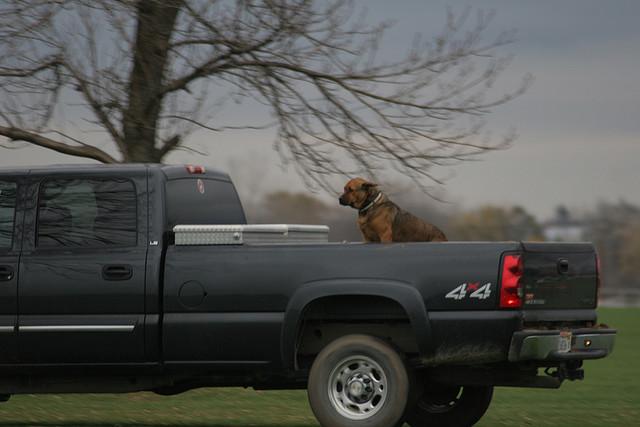What is the truck transporting?
Give a very brief answer. Dog. What color is the truck?
Write a very short answer. Black. What are there names?
Short answer required. Dog. Is this safe for the dog?
Quick response, please. No. What is in the bed of the truck?
Be succinct. Dog. Is the dog on a 4 wheeler?
Quick response, please. No. Is it sunny?
Keep it brief. No. Is the dog in the truck?
Answer briefly. Yes. Is the truck driving?
Keep it brief. Yes. Is it raining out?
Concise answer only. No. Does the tree have leaves?
Give a very brief answer. No. Is there anyone inside the truck?
Short answer required. Yes. Are there stickers on the rear window?
Concise answer only. Yes. What type of car is next to the dogs?
Answer briefly. Truck. What is on this truck?
Write a very short answer. Dog. 